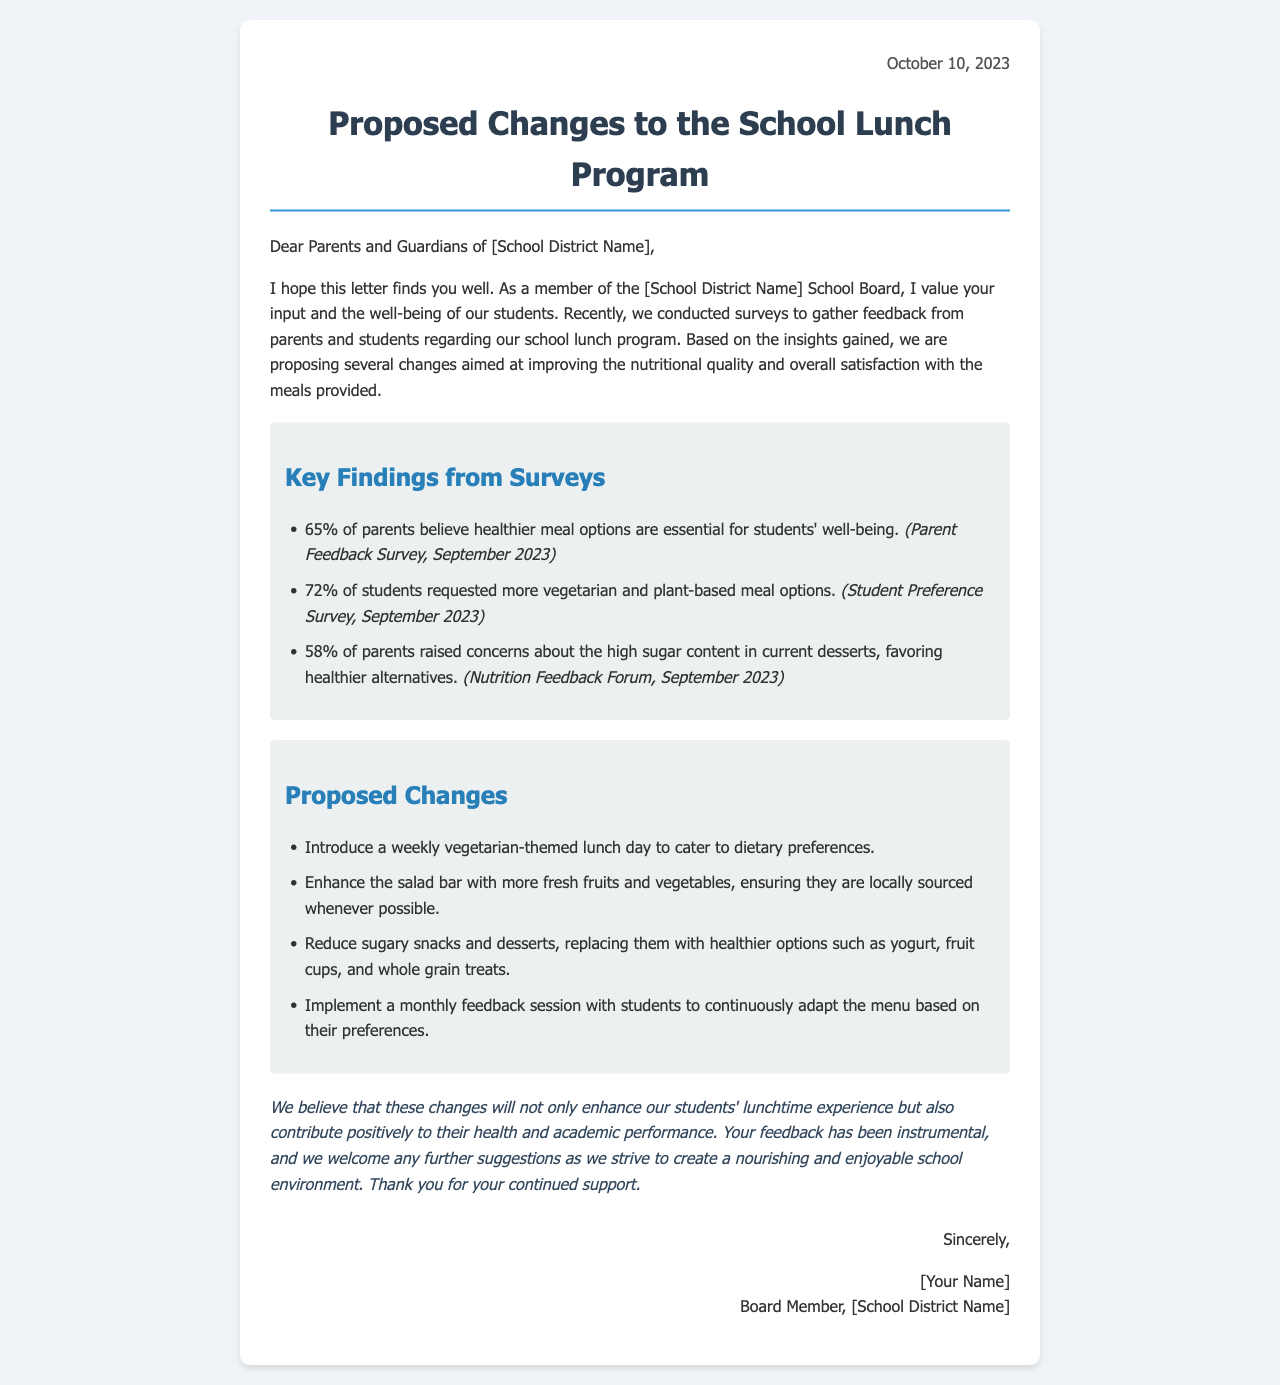What date was the letter written? The date mentioned at the top right corner of the letter indicates when it was written.
Answer: October 10, 2023 What percentage of parents believe healthier meal options are essential? This information is derived from the key findings section discussing parents' opinions on meal options.
Answer: 65% How many students requested more vegetarian options? The document provides specific survey results regarding student preferences for meal options.
Answer: 72% What is one proposed change to the school lunch program? The letter outlines several proposed changes derived from the feedback collected from surveys and forums.
Answer: Introduce a weekly vegetarian-themed lunch day What sources were cited for the findings mentioned? The findings in the letter reference specific surveys and forums that were conducted, indicating the source of the information.
Answer: Parent Feedback Survey, Student Preference Survey, Nutrition Feedback Forum What is the concluded benefit of the proposed changes? The letter summarizes the overall aims of the proposed changes in the conclusion section.
Answer: Enhance students' lunchtime experience Who signed the letter? The signature section of the letter reveals who is behind the correspondence.
Answer: [Your Name] What preference did 58% of parents express regarding desserts? The letter provides insights into parents' concerns related to the desserts currently being served.
Answer: Healthier alternatives 